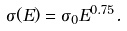<formula> <loc_0><loc_0><loc_500><loc_500>\sigma ( E ) = \sigma _ { 0 } E ^ { 0 . 7 5 } .</formula> 